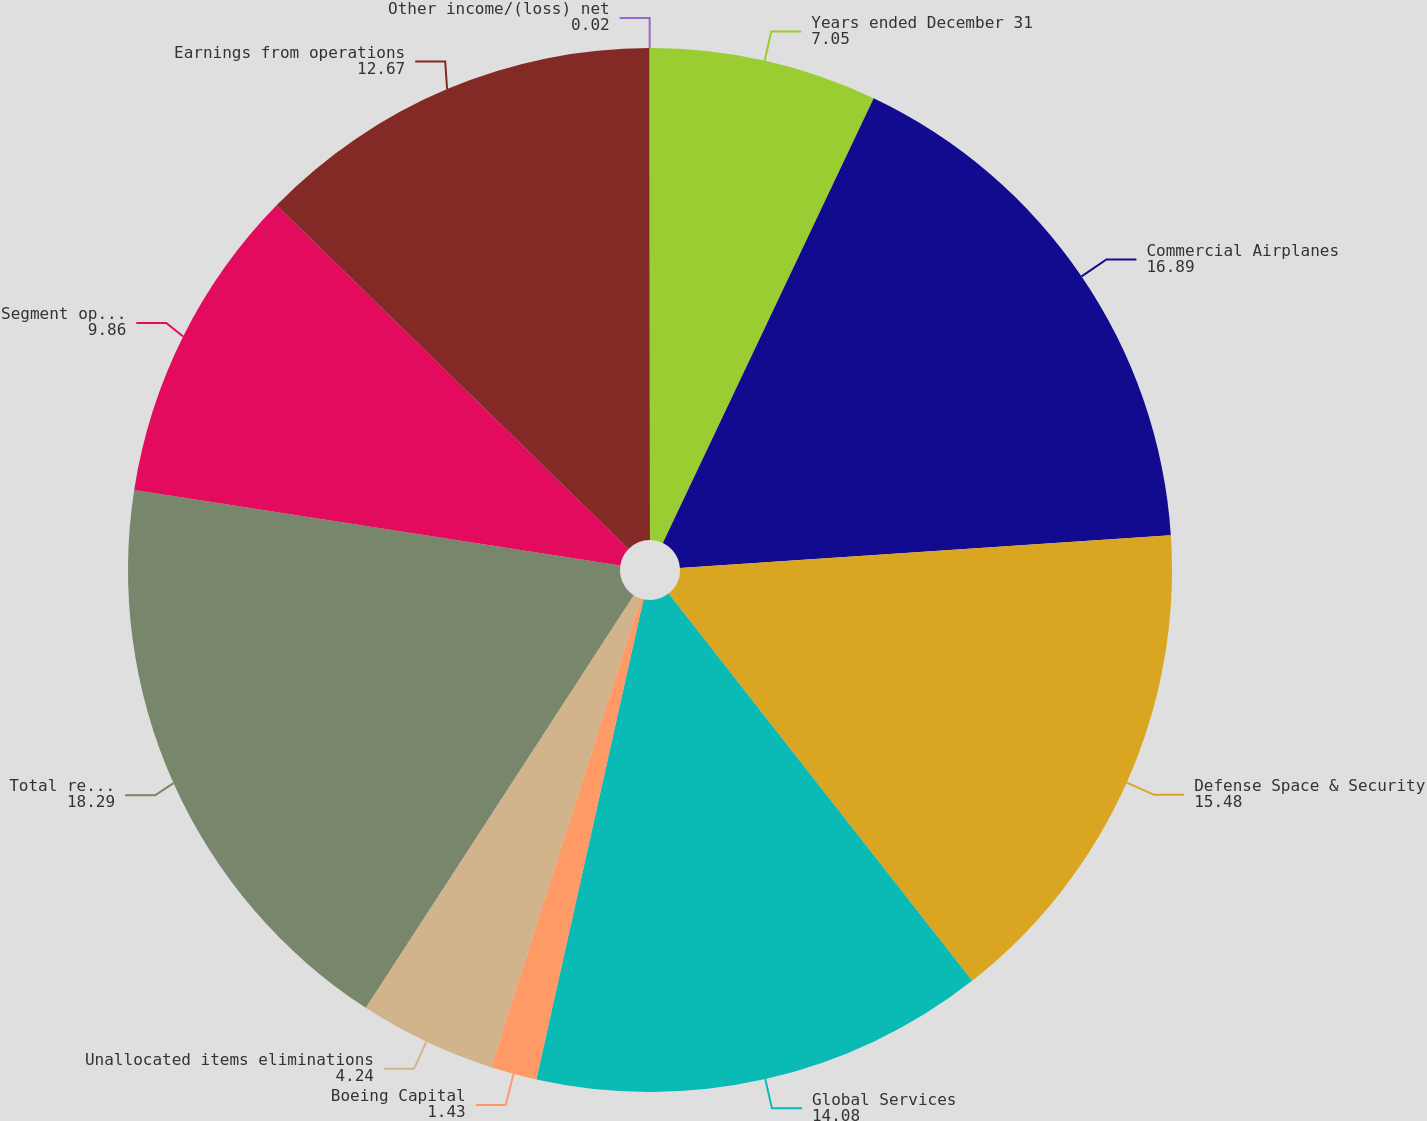Convert chart to OTSL. <chart><loc_0><loc_0><loc_500><loc_500><pie_chart><fcel>Years ended December 31<fcel>Commercial Airplanes<fcel>Defense Space & Security<fcel>Global Services<fcel>Boeing Capital<fcel>Unallocated items eliminations<fcel>Total revenues<fcel>Segment operating profit<fcel>Earnings from operations<fcel>Other income/(loss) net<nl><fcel>7.05%<fcel>16.89%<fcel>15.48%<fcel>14.08%<fcel>1.43%<fcel>4.24%<fcel>18.29%<fcel>9.86%<fcel>12.67%<fcel>0.02%<nl></chart> 